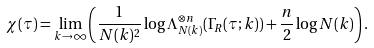Convert formula to latex. <formula><loc_0><loc_0><loc_500><loc_500>\chi ( \tau ) = \lim _ { k \rightarrow \infty } \left ( \frac { 1 } { N ( k ) ^ { 2 } } \log \Lambda _ { N ( k ) } ^ { \otimes n } ( \Gamma _ { R } ( \tau ; k ) ) + \frac { n } { 2 } \log N ( k ) \right ) .</formula> 